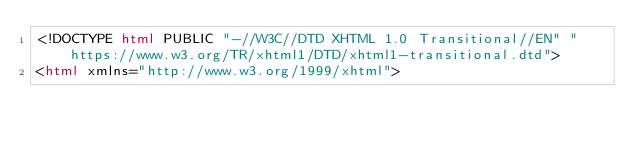<code> <loc_0><loc_0><loc_500><loc_500><_HTML_><!DOCTYPE html PUBLIC "-//W3C//DTD XHTML 1.0 Transitional//EN" "https://www.w3.org/TR/xhtml1/DTD/xhtml1-transitional.dtd">
<html xmlns="http://www.w3.org/1999/xhtml"></code> 